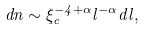<formula> <loc_0><loc_0><loc_500><loc_500>d n \sim \xi _ { c } ^ { - 4 + \alpha } l ^ { - \alpha } d l ,</formula> 